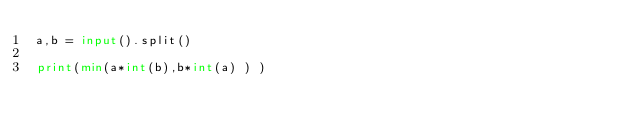<code> <loc_0><loc_0><loc_500><loc_500><_Python_>a,b = input().split()
 
print(min(a*int(b),b*int(a) ) )
</code> 